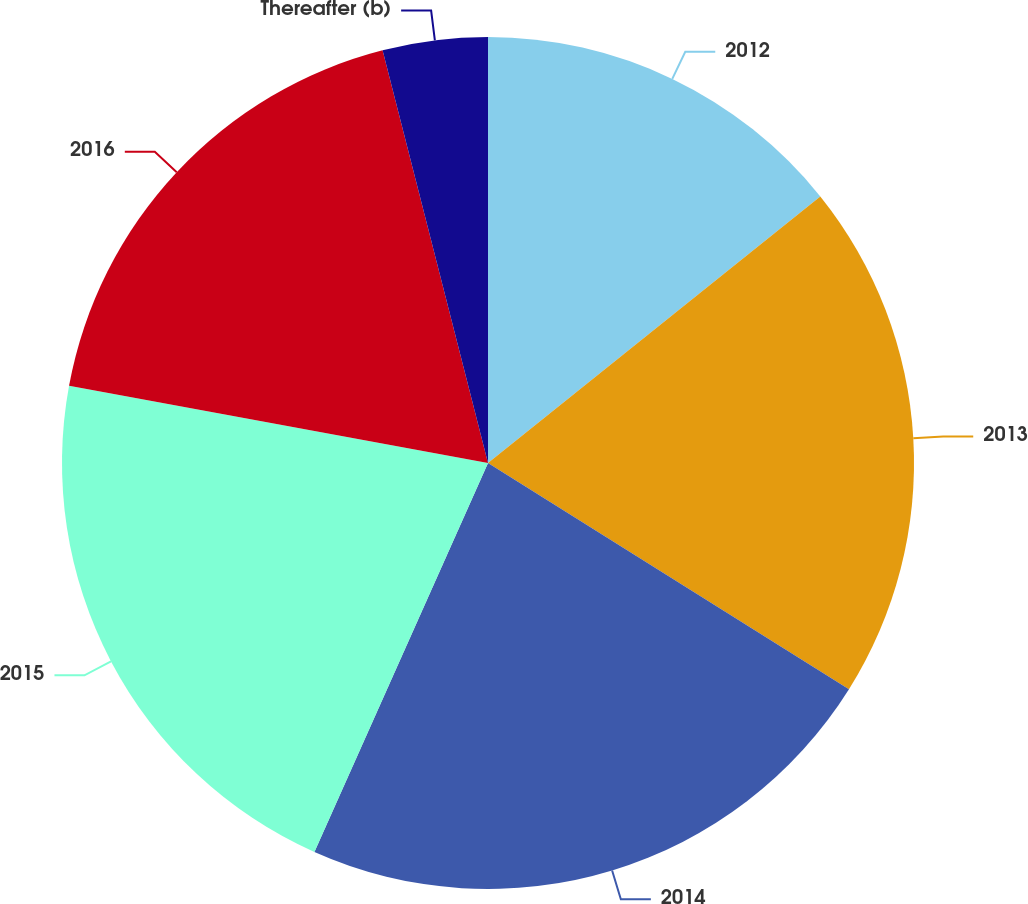Convert chart. <chart><loc_0><loc_0><loc_500><loc_500><pie_chart><fcel>2012<fcel>2013<fcel>2014<fcel>2015<fcel>2016<fcel>Thereafter (b)<nl><fcel>14.24%<fcel>19.67%<fcel>22.77%<fcel>21.22%<fcel>18.12%<fcel>3.98%<nl></chart> 